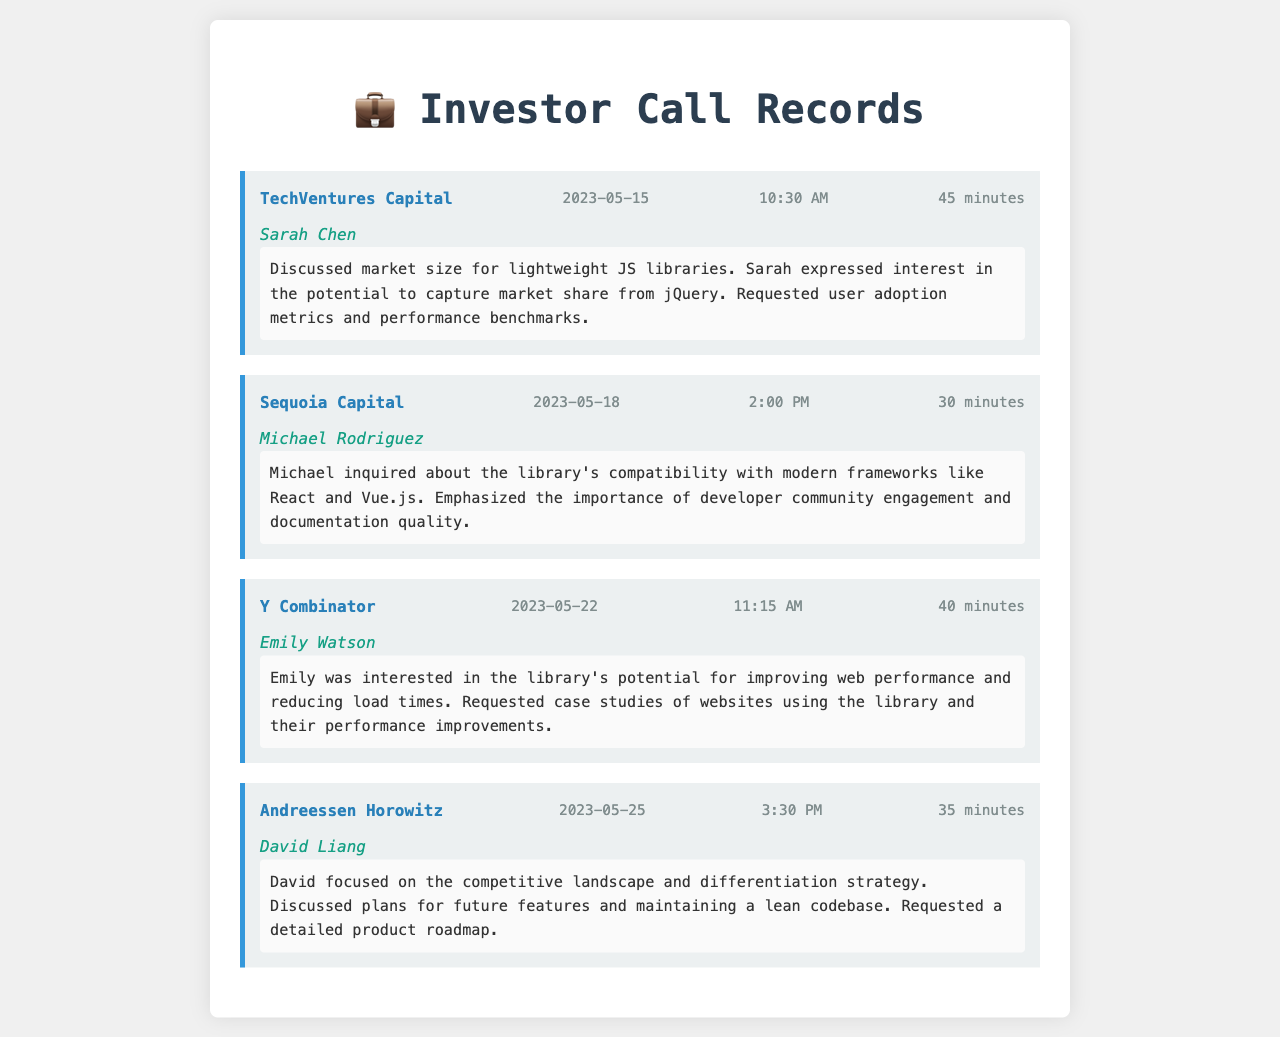What company did Sarah Chen represent? Sarah Chen was the caller during the conference call with TechVentures Capital, which is the company mentioned in the document.
Answer: TechVentures Capital What was the date of the call with Michael Rodriguez? The call with Michael Rodriguez took place on May 18, 2023, as stated in the call record.
Answer: 2023-05-18 How long was the call with David Liang? The duration of the call with David Liang is recorded as 35 minutes in the document.
Answer: 35 minutes What was discussed in the call with Emily Watson regarding performance? Emily Watson was interested in the library's potential for improving web performance and reducing load times, as noted in the call.
Answer: Improving web performance Which call involved a discussion about compatibility with modern frameworks? The call that involved compatibility discussions was with Michael Rodriguez from Sequoia Capital.
Answer: Sequoia Capital What did David Liang request during his call? David Liang requested a detailed product roadmap during his call based on the conversation content.
Answer: Detailed product roadmap How many calls were conducted with potential investors? The document lists a total of four calls conducted with different investors regarding the lightweight JavaScript library.
Answer: Four calls What is a notable request made by Sarah Chen? Sarah Chen requested user adoption metrics and performance benchmarks during her call.
Answer: User adoption metrics What company is mentioned in relation to a request for case studies? Y Combinator is the company mentioned in relation to Emily Watson's request for case studies.
Answer: Y Combinator 